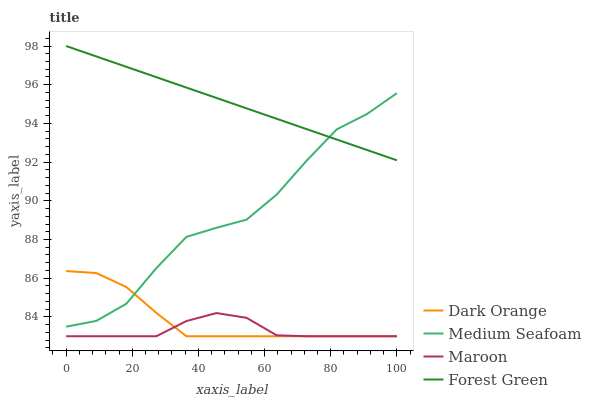Does Maroon have the minimum area under the curve?
Answer yes or no. Yes. Does Forest Green have the maximum area under the curve?
Answer yes or no. Yes. Does Medium Seafoam have the minimum area under the curve?
Answer yes or no. No. Does Medium Seafoam have the maximum area under the curve?
Answer yes or no. No. Is Forest Green the smoothest?
Answer yes or no. Yes. Is Medium Seafoam the roughest?
Answer yes or no. Yes. Is Medium Seafoam the smoothest?
Answer yes or no. No. Is Forest Green the roughest?
Answer yes or no. No. Does Medium Seafoam have the lowest value?
Answer yes or no. No. Does Medium Seafoam have the highest value?
Answer yes or no. No. Is Dark Orange less than Forest Green?
Answer yes or no. Yes. Is Medium Seafoam greater than Maroon?
Answer yes or no. Yes. Does Dark Orange intersect Forest Green?
Answer yes or no. No. 